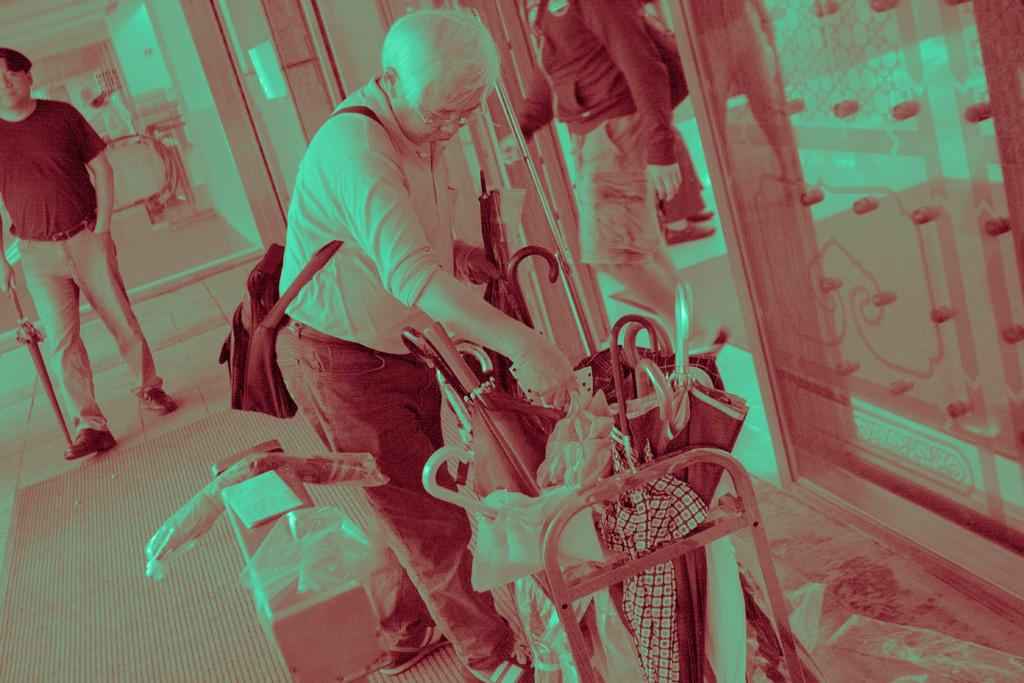What is the main activity of the person in the image? The person in the image is keening umbrellas in a rack. What object is located beside the person? There is a box beside the person. Can you describe the other person visible in the image? The other person is standing and holding an umbrella. What type of robin can be seen perched on the umbrella rack in the image? There is no robin present in the image; it features a person keening umbrellas in a rack and another person holding an umbrella. How many mittens are visible in the image? There are no mittens present in the image. 